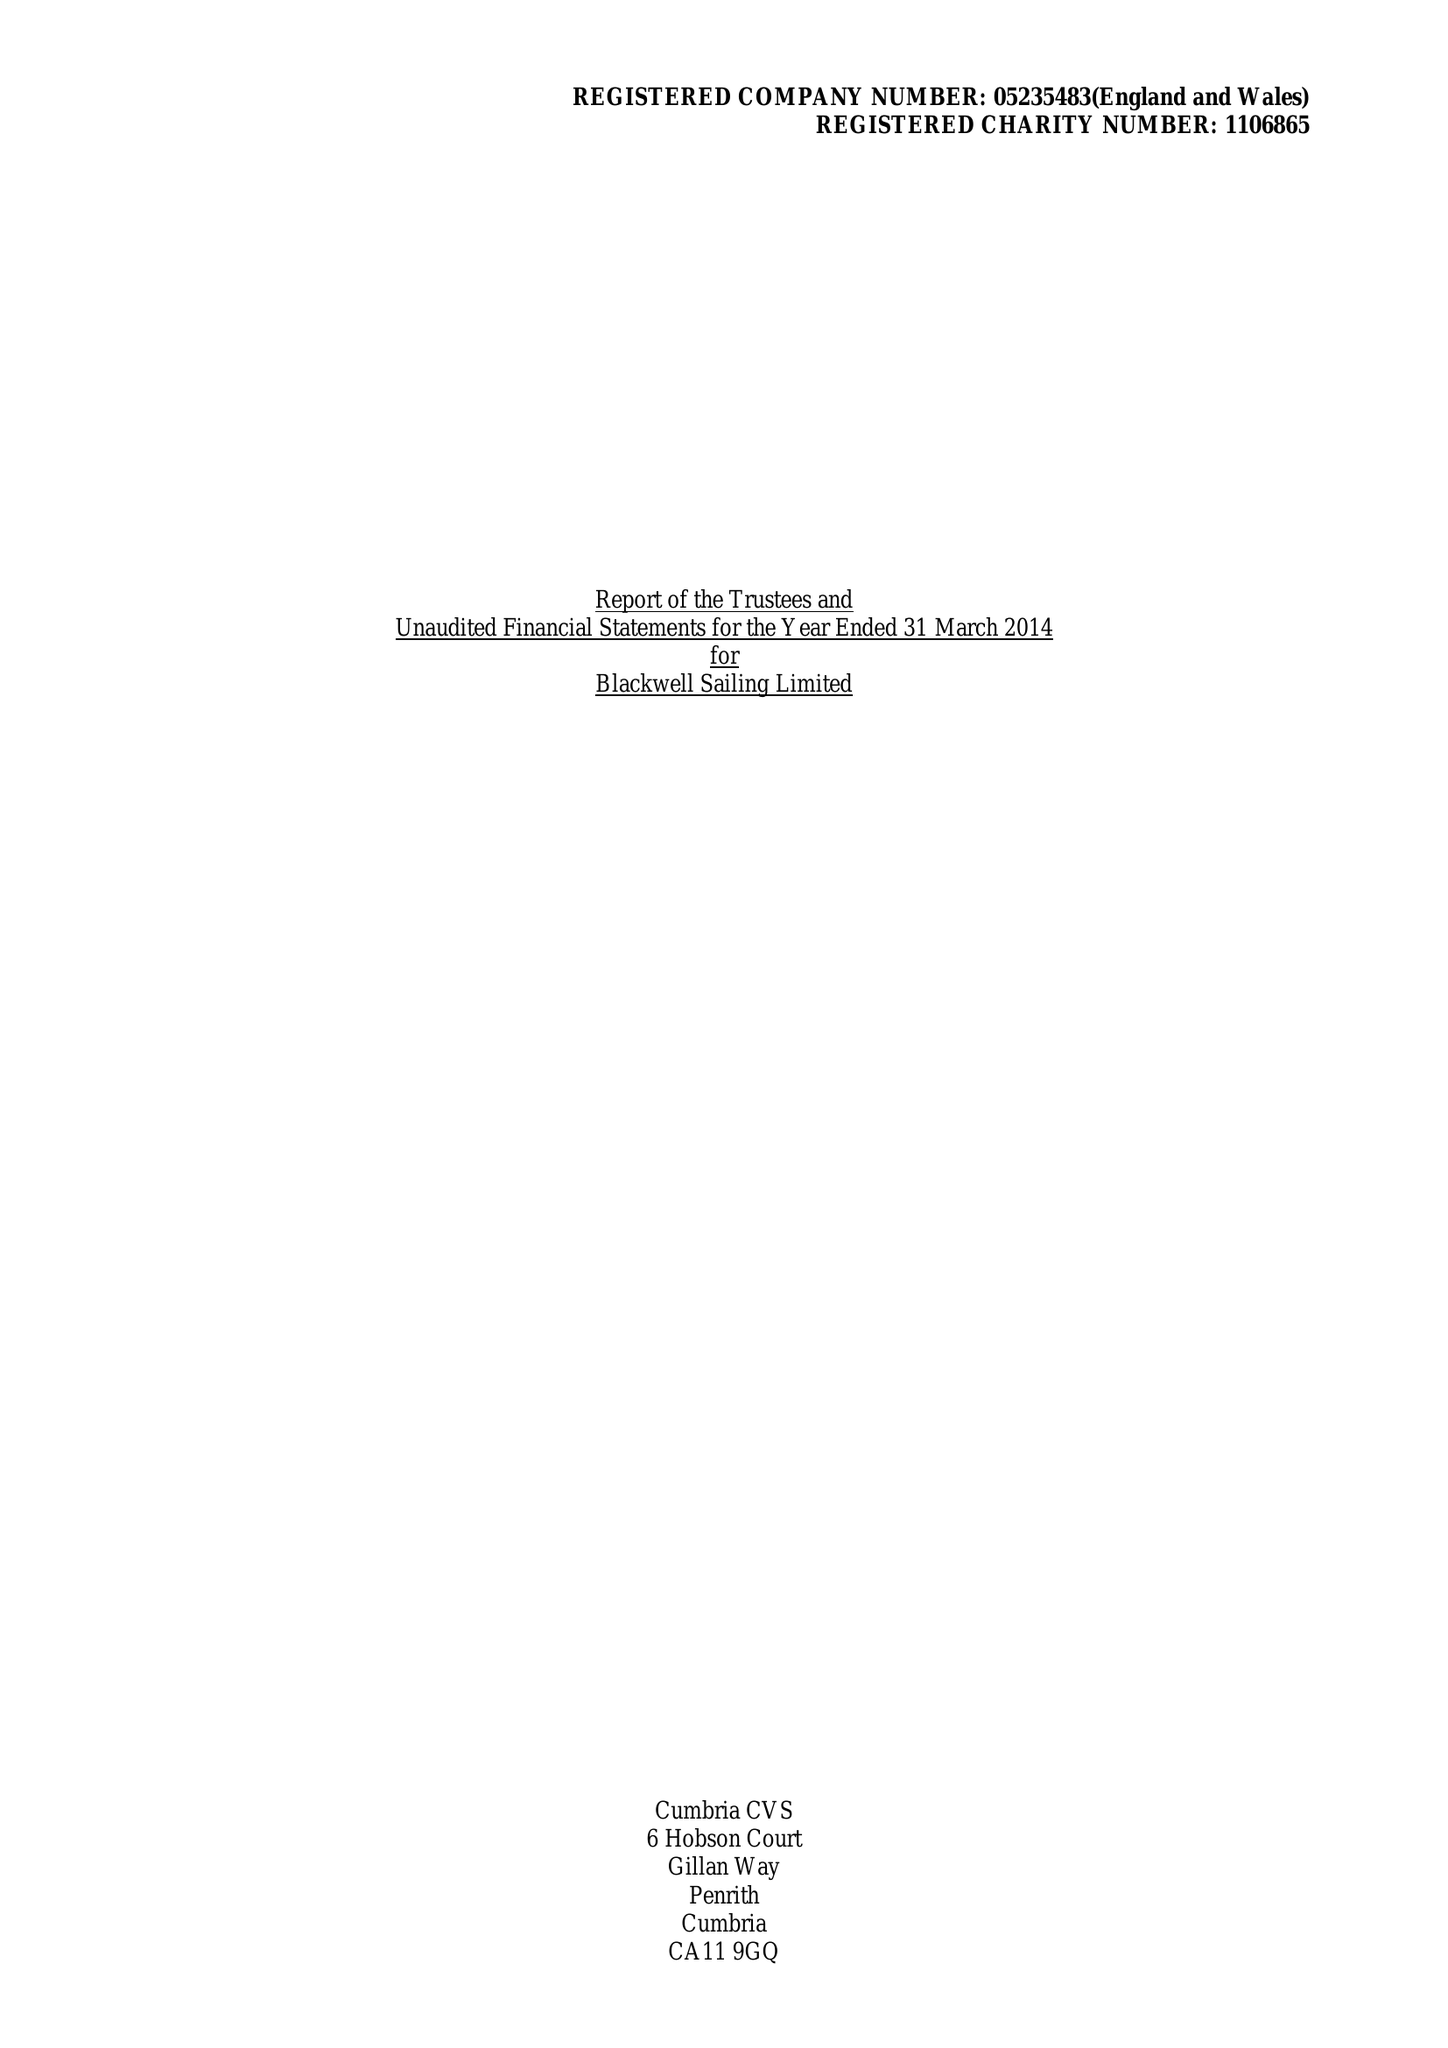What is the value for the spending_annually_in_british_pounds?
Answer the question using a single word or phrase. 61081.00 